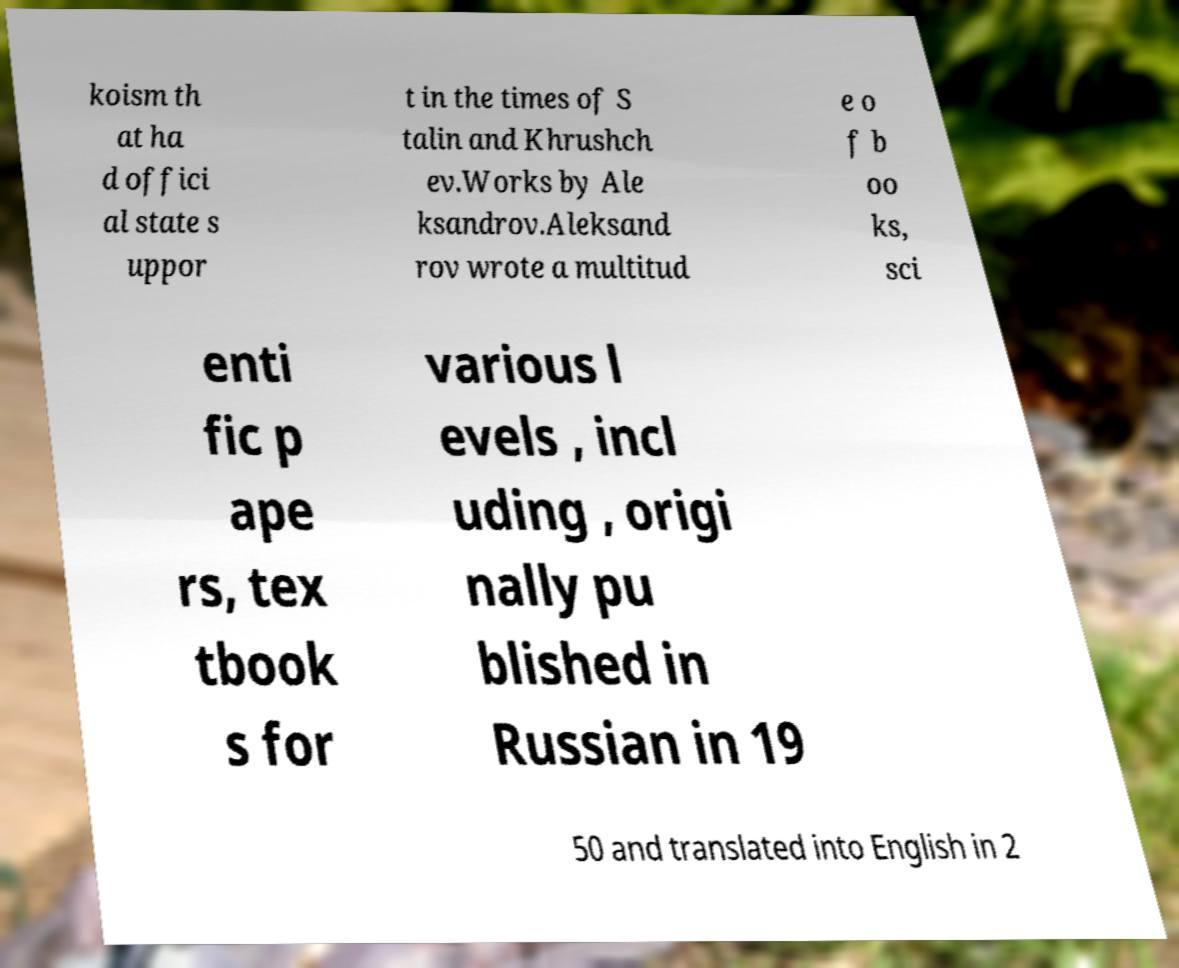Can you read and provide the text displayed in the image?This photo seems to have some interesting text. Can you extract and type it out for me? koism th at ha d offici al state s uppor t in the times of S talin and Khrushch ev.Works by Ale ksandrov.Aleksand rov wrote a multitud e o f b oo ks, sci enti fic p ape rs, tex tbook s for various l evels , incl uding , origi nally pu blished in Russian in 19 50 and translated into English in 2 